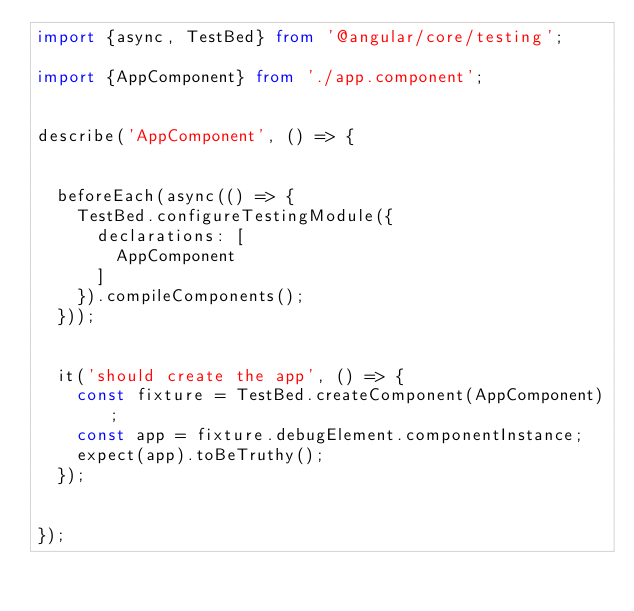<code> <loc_0><loc_0><loc_500><loc_500><_TypeScript_>import {async, TestBed} from '@angular/core/testing';

import {AppComponent} from './app.component';


describe('AppComponent', () => {


  beforeEach(async(() => {
    TestBed.configureTestingModule({
      declarations: [
        AppComponent
      ]
    }).compileComponents();
  }));


  it('should create the app', () => {
    const fixture = TestBed.createComponent(AppComponent);
    const app = fixture.debugElement.componentInstance;
    expect(app).toBeTruthy();
  });


});
</code> 